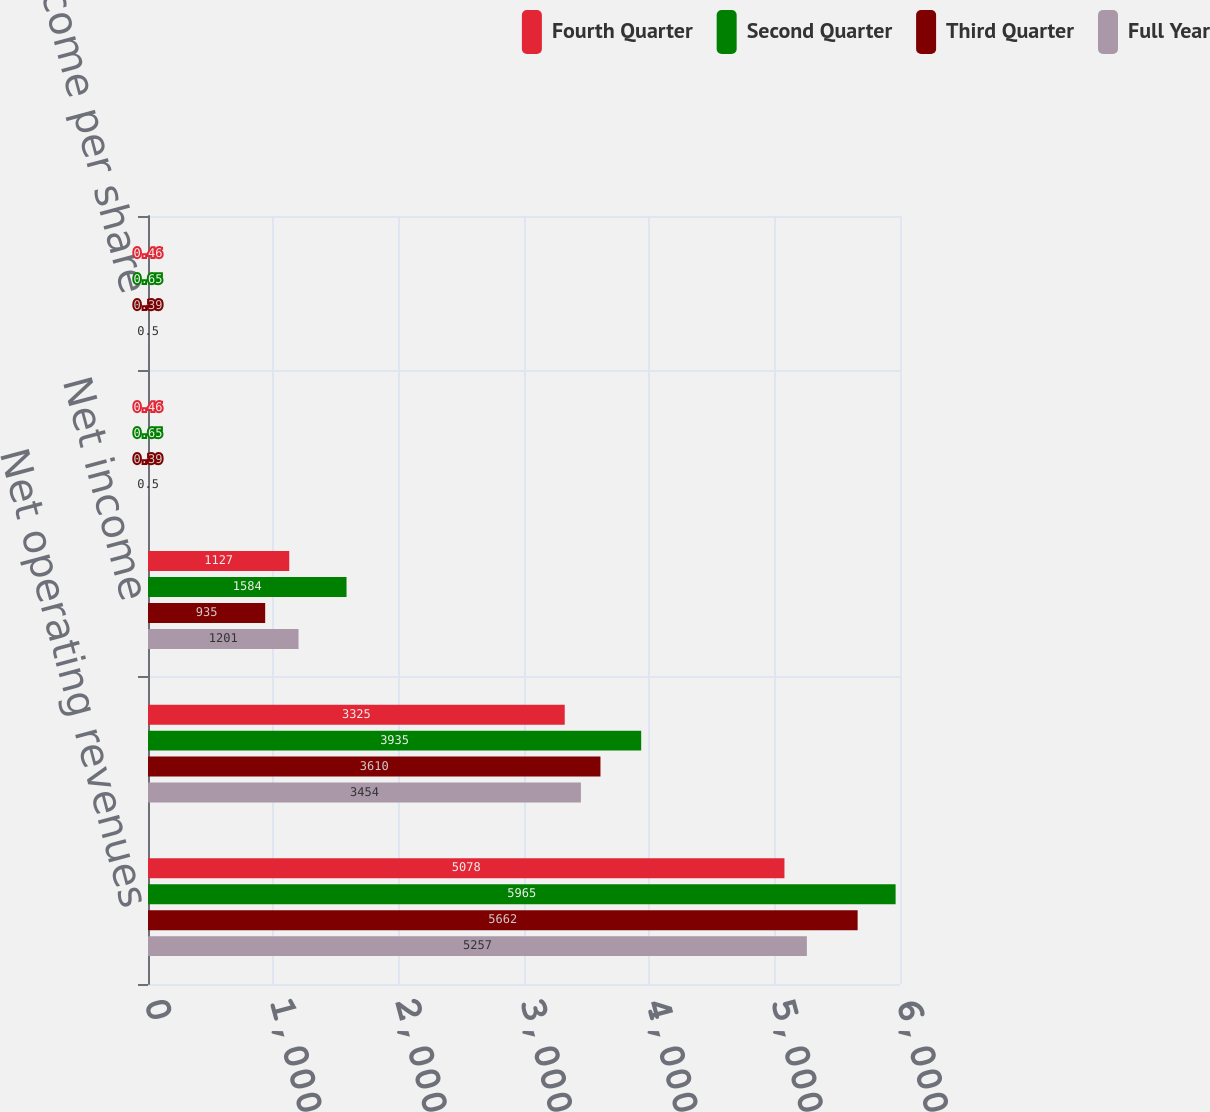<chart> <loc_0><loc_0><loc_500><loc_500><stacked_bar_chart><ecel><fcel>Net operating revenues<fcel>Gross profit<fcel>Net income<fcel>Basic net income per share<fcel>Diluted net income per share<nl><fcel>Fourth Quarter<fcel>5078<fcel>3325<fcel>1127<fcel>0.46<fcel>0.46<nl><fcel>Second Quarter<fcel>5965<fcel>3935<fcel>1584<fcel>0.65<fcel>0.65<nl><fcel>Third Quarter<fcel>5662<fcel>3610<fcel>935<fcel>0.39<fcel>0.39<nl><fcel>Full Year<fcel>5257<fcel>3454<fcel>1201<fcel>0.5<fcel>0.5<nl></chart> 